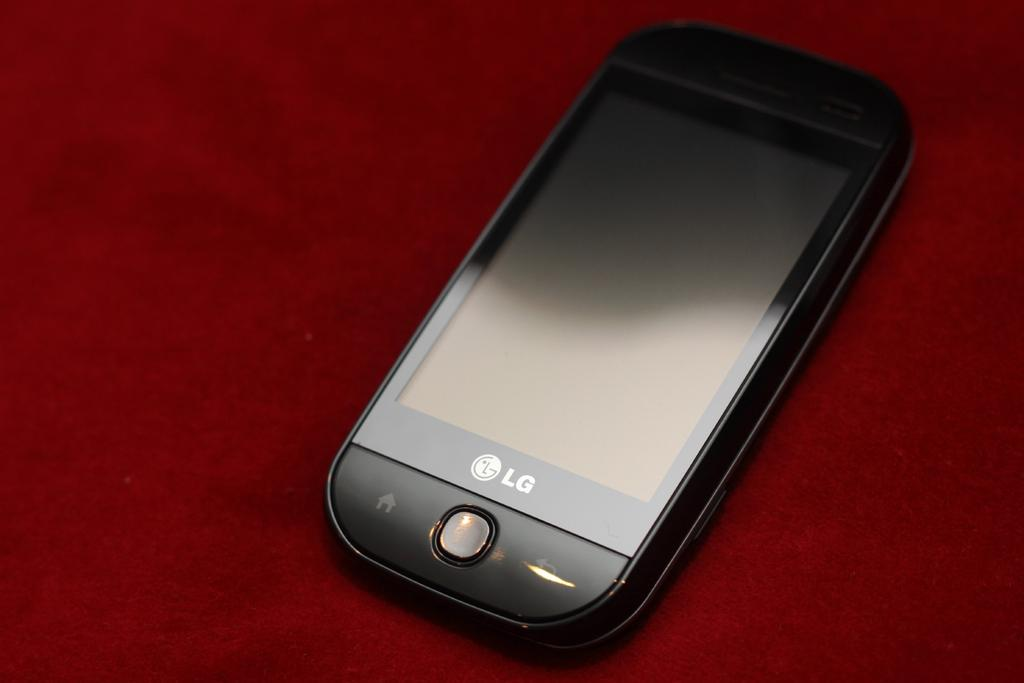<image>
Relay a brief, clear account of the picture shown. An LG brand cell phone is on top of a red background. 